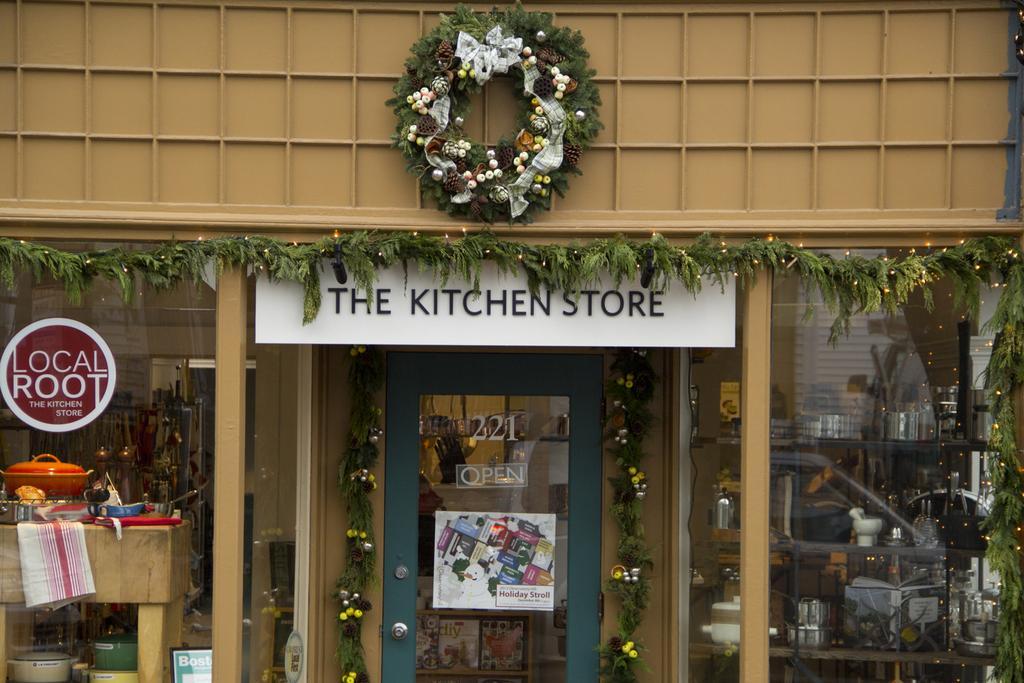Could you give a brief overview of what you see in this image? Here I can see a building. At the bottom, I can see the glasses and a door. There is a poster attached to the door and on the both sides of the door I can see artificial creepers. On the left side there is a table on which a cloth and few bowls are placed. Behind the glass, I can see few racks in which there are some bowls. At the top there are some artificial flowers and leaves are attached a board. 